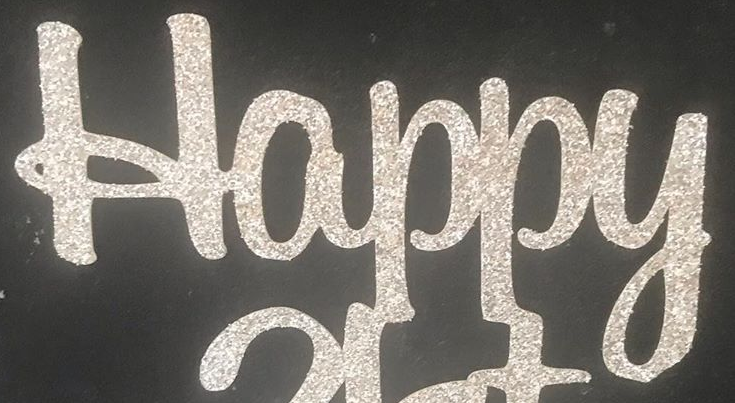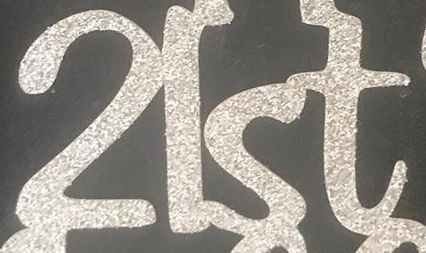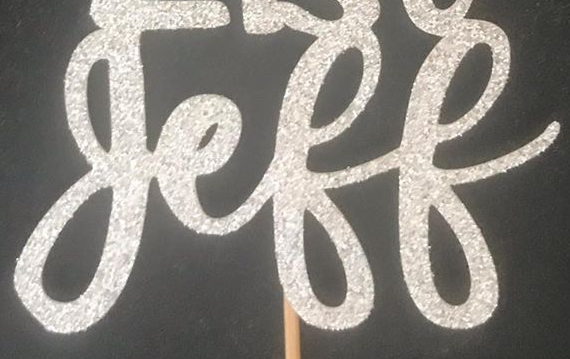What text is displayed in these images sequentially, separated by a semicolon? Happy; 2lst; geff 